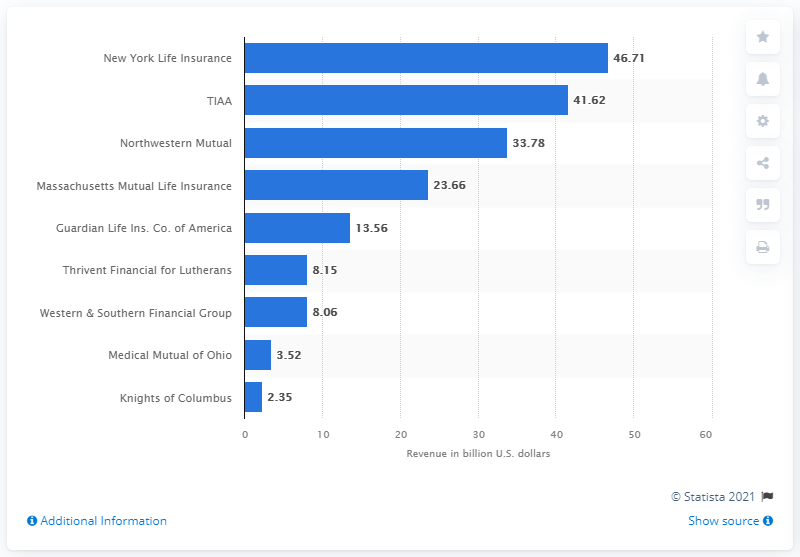Specify some key components in this picture. In 2020, the revenue of New York Life Insurance company was approximately 46.71 billion dollars. 